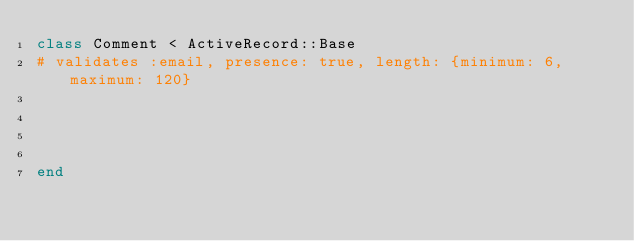<code> <loc_0><loc_0><loc_500><loc_500><_Ruby_>class Comment < ActiveRecord::Base
#	validates :email, presence: true, length: {minimum: 6, maximum: 120}




end
</code> 